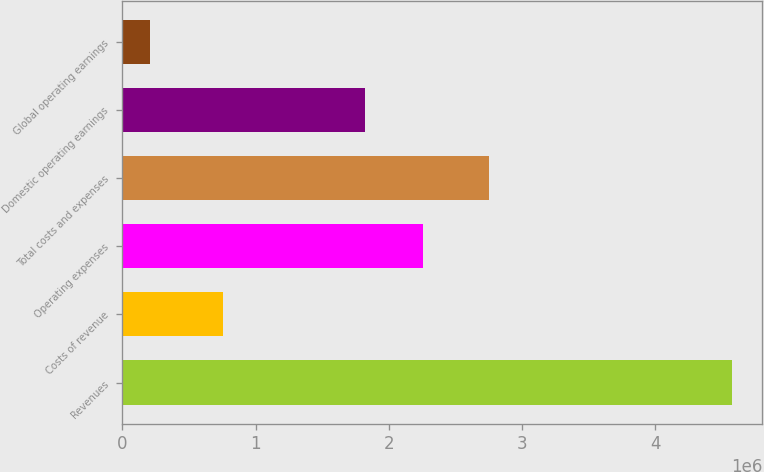Convert chart to OTSL. <chart><loc_0><loc_0><loc_500><loc_500><bar_chart><fcel>Revenues<fcel>Costs of revenue<fcel>Operating expenses<fcel>Total costs and expenses<fcel>Domestic operating earnings<fcel>Global operating earnings<nl><fcel>4.57517e+06<fcel>755729<fcel>2.25796e+06<fcel>2.75427e+06<fcel>1.8209e+06<fcel>204543<nl></chart> 